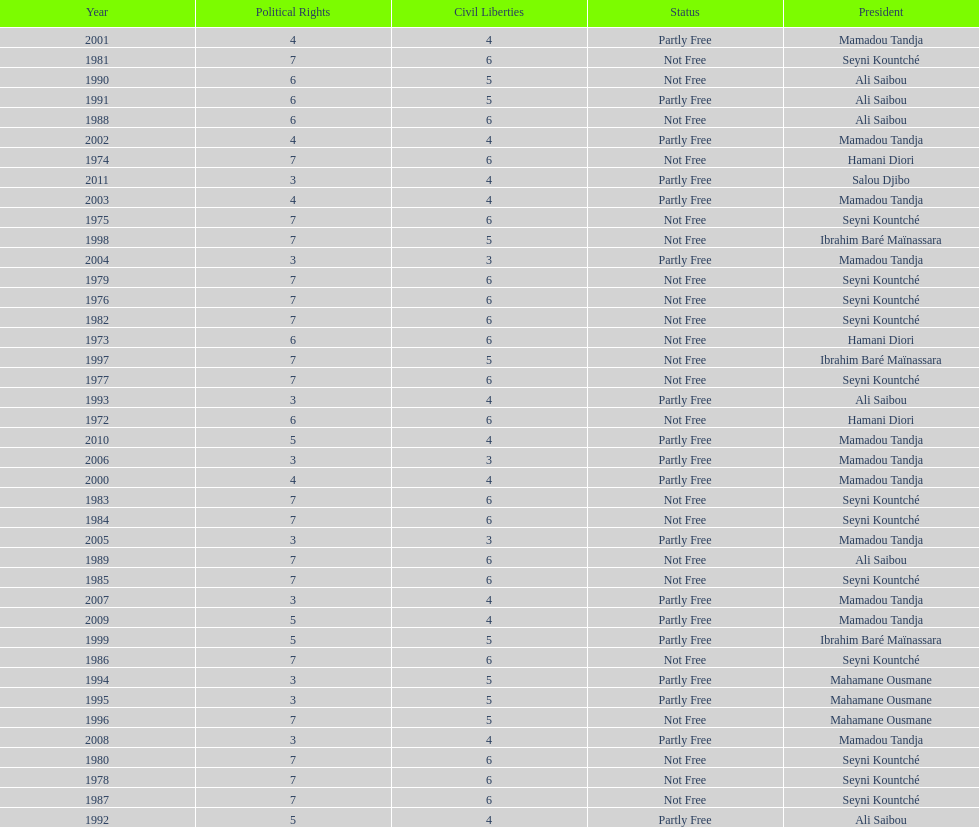What is the number of time seyni kountche has been president? 13. 